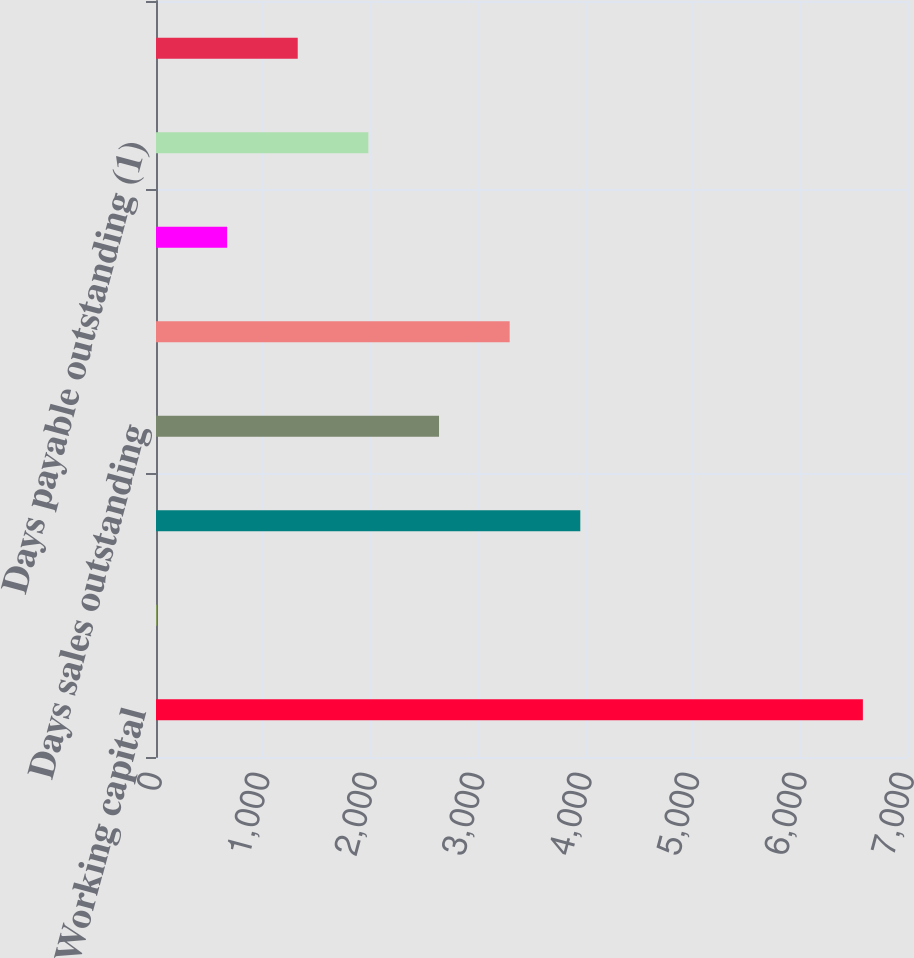<chart> <loc_0><loc_0><loc_500><loc_500><bar_chart><fcel>Working capital<fcel>Current ratio<fcel>Trade accounts receivable net<fcel>Days sales outstanding<fcel>Inventories<fcel>Inventory turns<fcel>Days payable outstanding (1)<fcel>T otal debt to total capital<nl><fcel>6580<fcel>4.11<fcel>3949.65<fcel>2634.47<fcel>3292.06<fcel>661.7<fcel>1976.88<fcel>1319.29<nl></chart> 